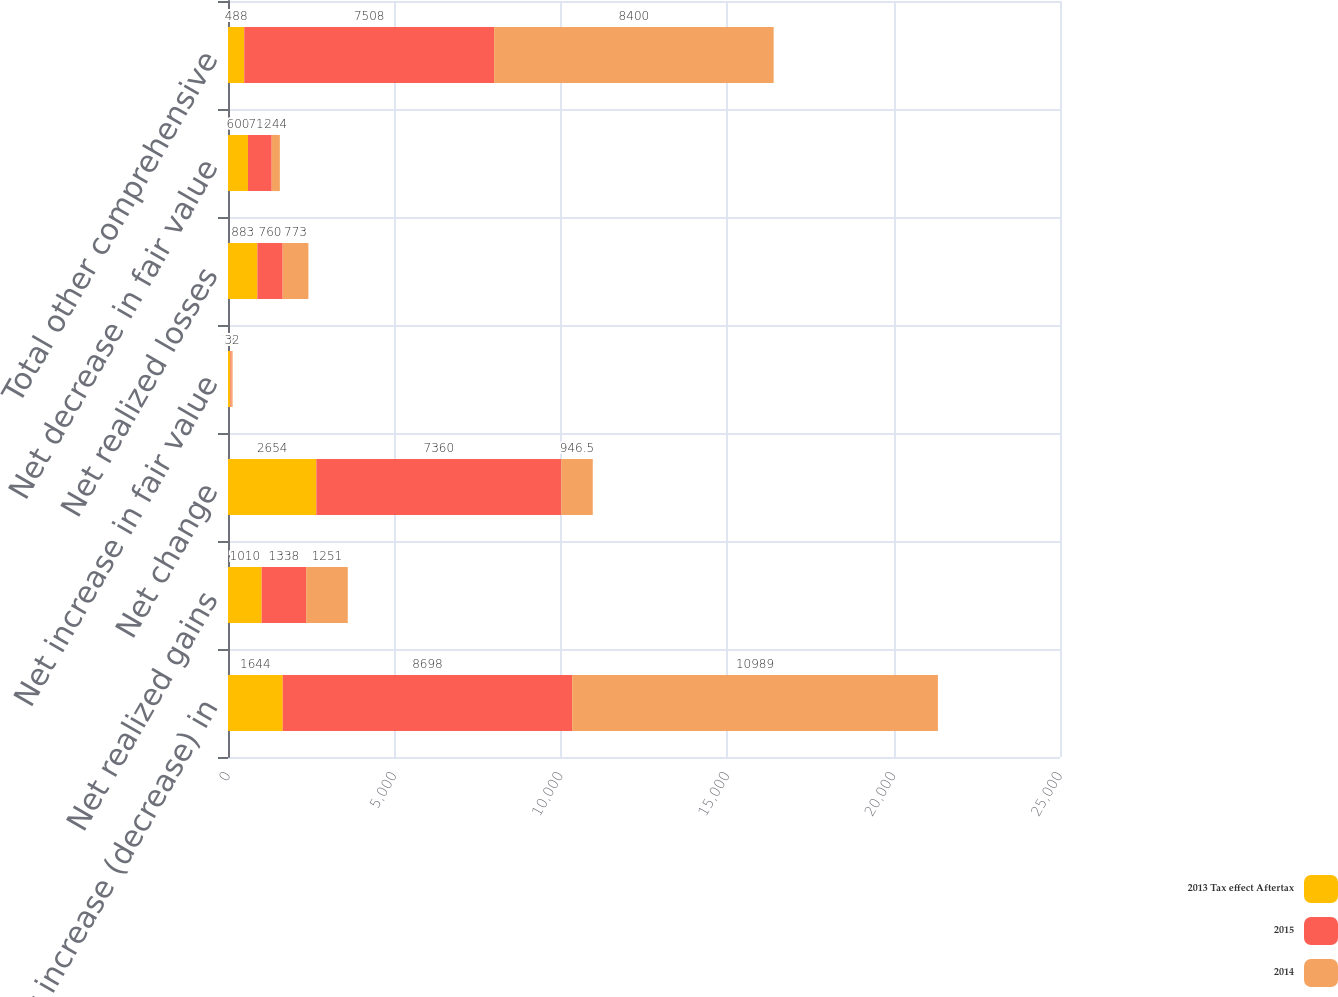Convert chart. <chart><loc_0><loc_0><loc_500><loc_500><stacked_bar_chart><ecel><fcel>Net increase (decrease) in<fcel>Net realized gains<fcel>Net change<fcel>Net increase in fair value<fcel>Net realized losses<fcel>Net decrease in fair value<fcel>Total other comprehensive<nl><fcel>2013 Tax effect Aftertax<fcel>1644<fcel>1010<fcel>2654<fcel>72<fcel>883<fcel>600<fcel>488<nl><fcel>2015<fcel>8698<fcel>1338<fcel>7360<fcel>34<fcel>760<fcel>714<fcel>7508<nl><fcel>2014<fcel>10989<fcel>1251<fcel>946.5<fcel>32<fcel>773<fcel>244<fcel>8400<nl></chart> 